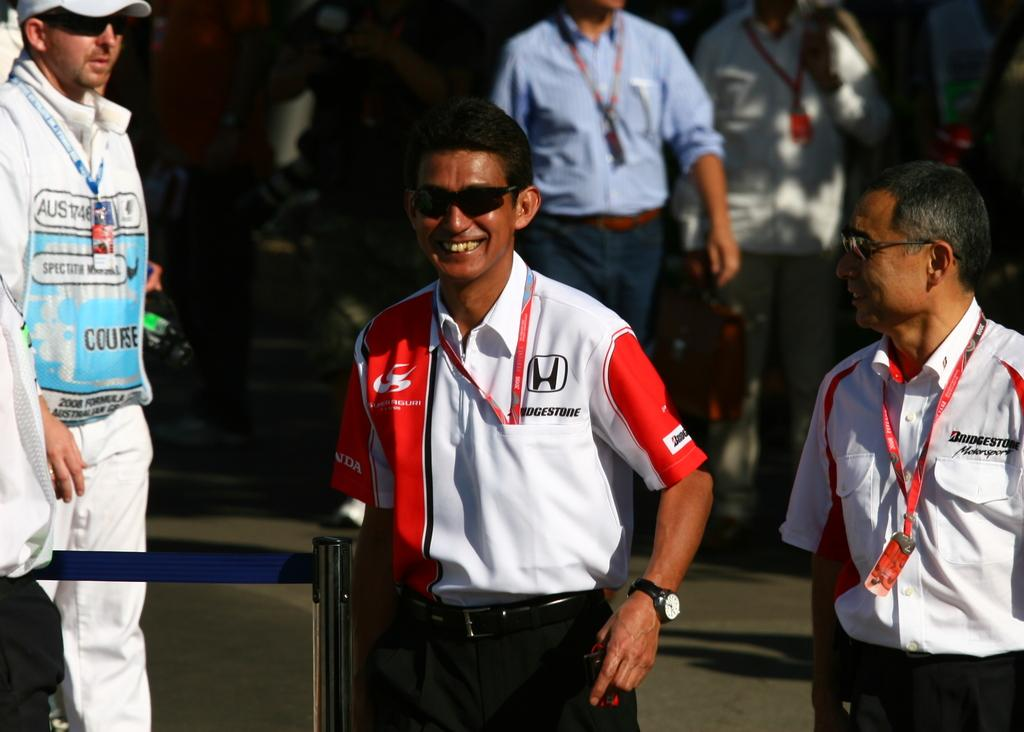<image>
Summarize the visual content of the image. A man in a white and red shirt that says Bridgestone on the chest smiles. 